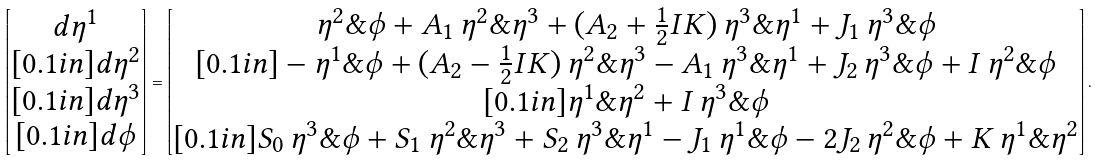<formula> <loc_0><loc_0><loc_500><loc_500>\begin{bmatrix} d \eta ^ { 1 } \\ [ 0 . 1 i n ] d \eta ^ { 2 } \\ [ 0 . 1 i n ] d \eta ^ { 3 } \\ [ 0 . 1 i n ] d \phi \end{bmatrix} = \begin{bmatrix} \eta ^ { 2 } \& \phi + A _ { 1 } \, \eta ^ { 2 } \& \eta ^ { 3 } + ( A _ { 2 } + \frac { 1 } { 2 } I K ) \, \eta ^ { 3 } \& \eta ^ { 1 } + J _ { 1 } \, \eta ^ { 3 } \& \phi \\ [ 0 . 1 i n ] - \eta ^ { 1 } \& \phi + ( A _ { 2 } - \frac { 1 } { 2 } I K ) \, \eta ^ { 2 } \& \eta ^ { 3 } - A _ { 1 } \, \eta ^ { 3 } \& \eta ^ { 1 } + J _ { 2 } \, \eta ^ { 3 } \& \phi + I \, \eta ^ { 2 } \& \phi \\ [ 0 . 1 i n ] \eta ^ { 1 } \& \eta ^ { 2 } + I \, \eta ^ { 3 } \& \phi \\ [ 0 . 1 i n ] S _ { 0 } \, \eta ^ { 3 } \& \phi + S _ { 1 } \, \eta ^ { 2 } \& \eta ^ { 3 } + S _ { 2 } \, \eta ^ { 3 } \& \eta ^ { 1 } - J _ { 1 } \, \eta ^ { 1 } \& \phi - 2 J _ { 2 } \, \eta ^ { 2 } \& \phi + K \, \eta ^ { 1 } \& \eta ^ { 2 } \end{bmatrix} .</formula> 